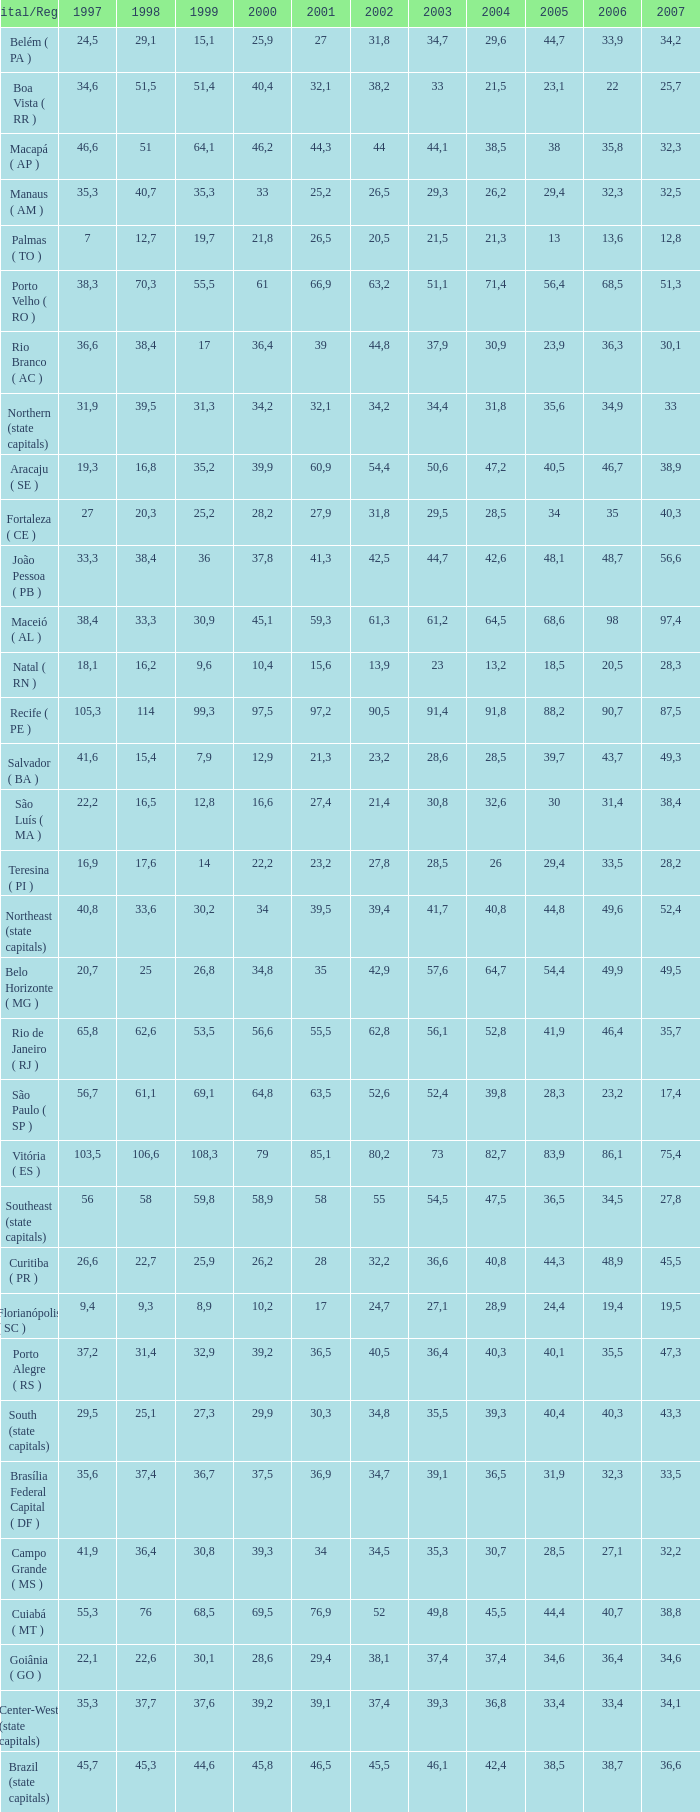How many 2007's have a 2003 less than 36,4, 27,9 as a 2001, and a 1999 less than 25,2? None. 